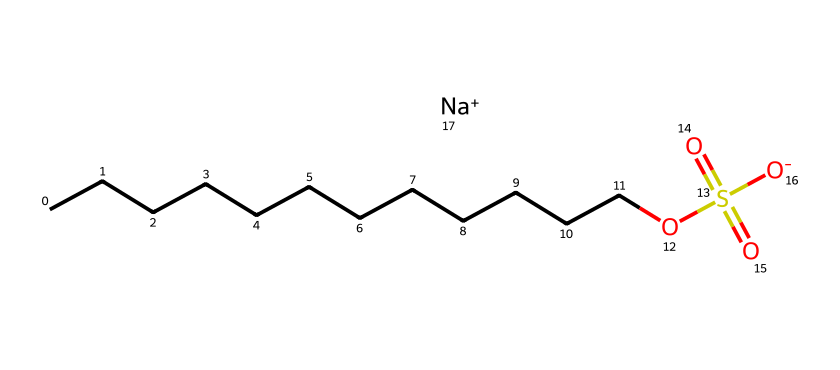What is the total number of carbon atoms in sodium lauryl sulfate? The SMILES representation shows a long carbon chain (CCCCCCCCCCCC), which counts for 12 carbon atoms. This is the main hydrophobic part of the molecule.
Answer: 12 What is the chemical functional group present in sodium lauryl sulfate? The chemical structure contains a sulfonate group (OS(=O)(=O)[O-]) which is characteristic of the sulfate functional group.
Answer: sulfate How many oxygen atoms are present in sodium lauryl sulfate? In the structure, there are four oxygen atoms: three in the sulfate group and one in the carbon chain (connected to the sulfur).
Answer: 4 What role does sodium play in sodium lauryl sulfate? Sodium acts as a counterion for the anionic sulfate group, helping to stabilize the molecule in solution and enhance its surfactant properties.
Answer: counterion Which part of sodium lauryl sulfate is hydrophobic? The long carbon chain (CCCCCCCCCCCC) is hydrophobic, as it does not interact favorably with water, while the sulfate group is hydrophilic.
Answer: carbon chain Explain why sodium lauryl sulfate is considered a surfactant. Sodium lauryl sulfate reduces surface tension between substances, and its structure has both hydrophilic (sulfate group) and hydrophobic (carbon chain) parts, allowing it to interact with both water and oils. This property is essential for cleaning and emulsifying.
Answer: reduces surface tension 